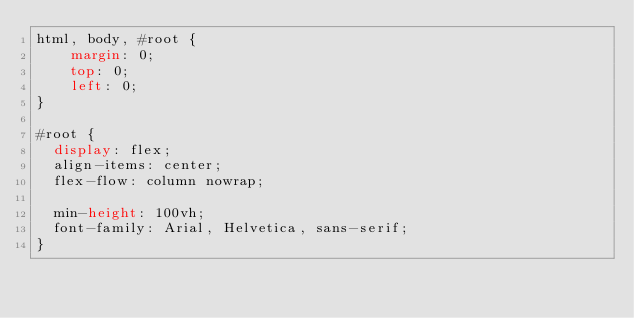<code> <loc_0><loc_0><loc_500><loc_500><_CSS_>html, body, #root {
    margin: 0;
    top: 0;
    left: 0;
}

#root {
  display: flex;
  align-items: center;
  flex-flow: column nowrap;

  min-height: 100vh;
  font-family: Arial, Helvetica, sans-serif;
}</code> 